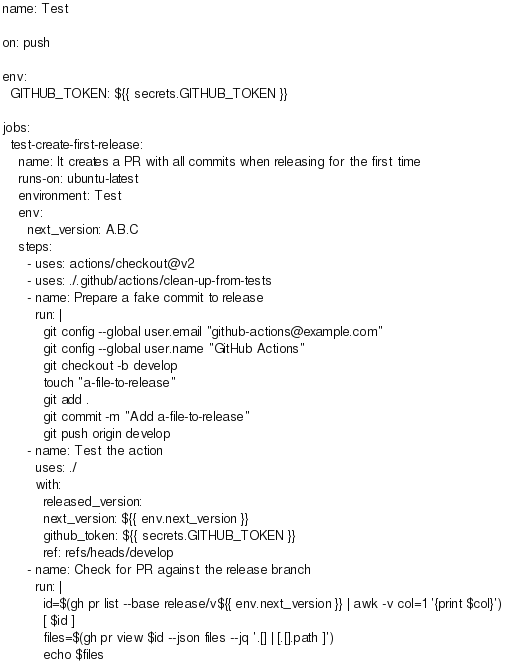<code> <loc_0><loc_0><loc_500><loc_500><_YAML_>name: Test

on: push

env:
  GITHUB_TOKEN: ${{ secrets.GITHUB_TOKEN }}

jobs:
  test-create-first-release:
    name: It creates a PR with all commits when releasing for the first time
    runs-on: ubuntu-latest
    environment: Test
    env:
      next_version: A.B.C
    steps:
      - uses: actions/checkout@v2
      - uses: ./.github/actions/clean-up-from-tests
      - name: Prepare a fake commit to release
        run: |
          git config --global user.email "github-actions@example.com"
          git config --global user.name "GitHub Actions"
          git checkout -b develop
          touch "a-file-to-release"
          git add .
          git commit -m "Add a-file-to-release"
          git push origin develop
      - name: Test the action
        uses: ./
        with:
          released_version:
          next_version: ${{ env.next_version }}
          github_token: ${{ secrets.GITHUB_TOKEN }}
          ref: refs/heads/develop
      - name: Check for PR against the release branch
        run: |
          id=$(gh pr list --base release/v${{ env.next_version }} | awk -v col=1 '{print $col}')
          [ $id ]
          files=$(gh pr view $id --json files --jq '.[] | [.[].path ]')
          echo $files</code> 